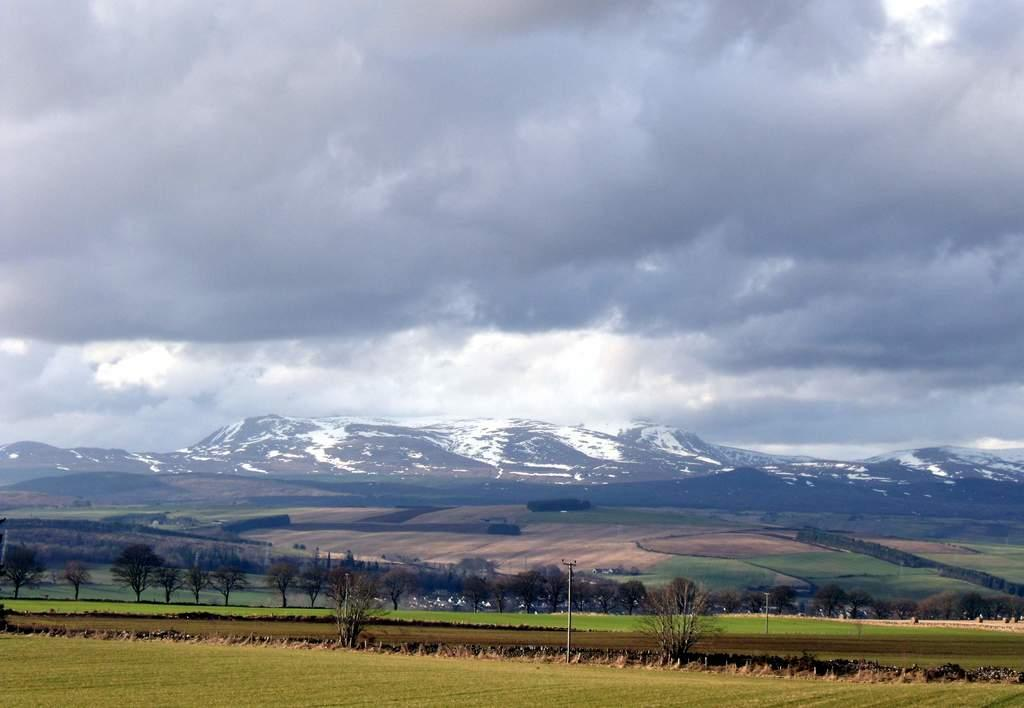What type of vegetation can be seen in the image? There is grass in the image. What other natural elements are present in the image? There are trees in the image. What can be seen in the distance in the background? In the background, there are hills with snow. What is visible in the sky in the image? Clouds are visible in the sky. What is the taste of the flame in the image? There is no flame present in the image, so it is not possible to determine its taste. 